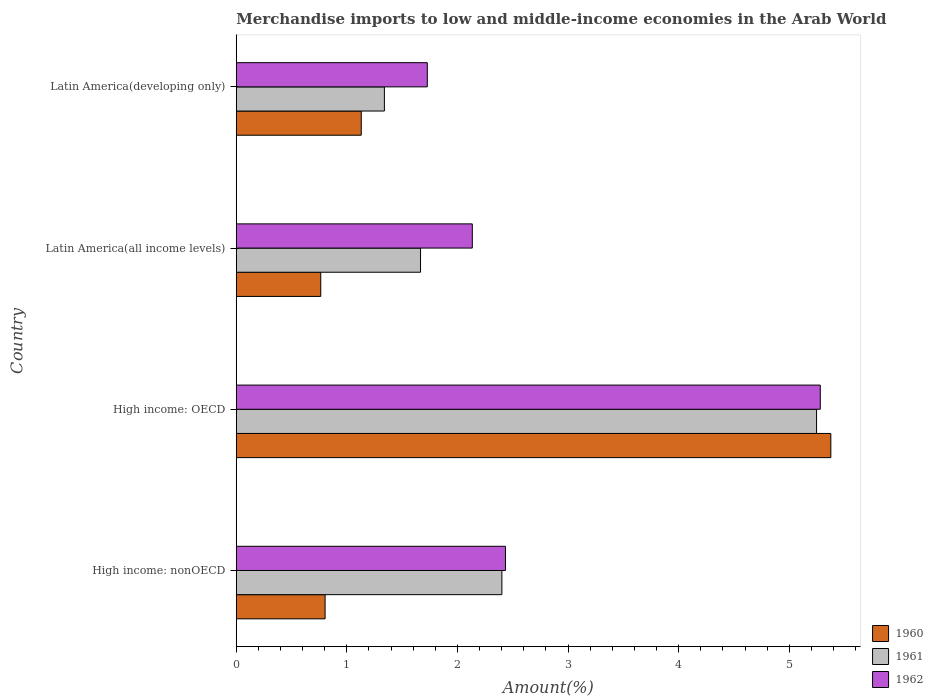How many different coloured bars are there?
Provide a succinct answer. 3. How many groups of bars are there?
Offer a terse response. 4. Are the number of bars per tick equal to the number of legend labels?
Your answer should be compact. Yes. How many bars are there on the 2nd tick from the top?
Offer a very short reply. 3. How many bars are there on the 3rd tick from the bottom?
Your response must be concise. 3. What is the label of the 3rd group of bars from the top?
Give a very brief answer. High income: OECD. What is the percentage of amount earned from merchandise imports in 1962 in Latin America(developing only)?
Make the answer very short. 1.73. Across all countries, what is the maximum percentage of amount earned from merchandise imports in 1961?
Ensure brevity in your answer.  5.25. Across all countries, what is the minimum percentage of amount earned from merchandise imports in 1962?
Give a very brief answer. 1.73. In which country was the percentage of amount earned from merchandise imports in 1962 maximum?
Provide a succinct answer. High income: OECD. In which country was the percentage of amount earned from merchandise imports in 1962 minimum?
Offer a very short reply. Latin America(developing only). What is the total percentage of amount earned from merchandise imports in 1962 in the graph?
Keep it short and to the point. 11.57. What is the difference between the percentage of amount earned from merchandise imports in 1960 in Latin America(all income levels) and that in Latin America(developing only)?
Ensure brevity in your answer.  -0.37. What is the difference between the percentage of amount earned from merchandise imports in 1960 in Latin America(all income levels) and the percentage of amount earned from merchandise imports in 1962 in Latin America(developing only)?
Your answer should be very brief. -0.96. What is the average percentage of amount earned from merchandise imports in 1962 per country?
Give a very brief answer. 2.89. What is the difference between the percentage of amount earned from merchandise imports in 1960 and percentage of amount earned from merchandise imports in 1962 in Latin America(all income levels)?
Make the answer very short. -1.37. What is the ratio of the percentage of amount earned from merchandise imports in 1960 in Latin America(all income levels) to that in Latin America(developing only)?
Your answer should be very brief. 0.68. Is the difference between the percentage of amount earned from merchandise imports in 1960 in High income: nonOECD and Latin America(all income levels) greater than the difference between the percentage of amount earned from merchandise imports in 1962 in High income: nonOECD and Latin America(all income levels)?
Your response must be concise. No. What is the difference between the highest and the second highest percentage of amount earned from merchandise imports in 1960?
Keep it short and to the point. 4.25. What is the difference between the highest and the lowest percentage of amount earned from merchandise imports in 1962?
Your answer should be very brief. 3.55. Is the sum of the percentage of amount earned from merchandise imports in 1960 in High income: OECD and Latin America(all income levels) greater than the maximum percentage of amount earned from merchandise imports in 1962 across all countries?
Provide a short and direct response. Yes. What does the 2nd bar from the top in Latin America(all income levels) represents?
Ensure brevity in your answer.  1961. What does the 2nd bar from the bottom in High income: nonOECD represents?
Provide a succinct answer. 1961. Is it the case that in every country, the sum of the percentage of amount earned from merchandise imports in 1961 and percentage of amount earned from merchandise imports in 1962 is greater than the percentage of amount earned from merchandise imports in 1960?
Your answer should be very brief. Yes. What is the difference between two consecutive major ticks on the X-axis?
Offer a very short reply. 1. Does the graph contain any zero values?
Keep it short and to the point. No. How many legend labels are there?
Your answer should be very brief. 3. What is the title of the graph?
Give a very brief answer. Merchandise imports to low and middle-income economies in the Arab World. What is the label or title of the X-axis?
Give a very brief answer. Amount(%). What is the Amount(%) in 1960 in High income: nonOECD?
Make the answer very short. 0.8. What is the Amount(%) in 1961 in High income: nonOECD?
Provide a succinct answer. 2.4. What is the Amount(%) in 1962 in High income: nonOECD?
Give a very brief answer. 2.43. What is the Amount(%) in 1960 in High income: OECD?
Provide a succinct answer. 5.38. What is the Amount(%) of 1961 in High income: OECD?
Ensure brevity in your answer.  5.25. What is the Amount(%) of 1962 in High income: OECD?
Your answer should be very brief. 5.28. What is the Amount(%) in 1960 in Latin America(all income levels)?
Provide a succinct answer. 0.76. What is the Amount(%) of 1961 in Latin America(all income levels)?
Your response must be concise. 1.67. What is the Amount(%) of 1962 in Latin America(all income levels)?
Your answer should be compact. 2.13. What is the Amount(%) in 1960 in Latin America(developing only)?
Keep it short and to the point. 1.13. What is the Amount(%) of 1961 in Latin America(developing only)?
Your response must be concise. 1.34. What is the Amount(%) in 1962 in Latin America(developing only)?
Make the answer very short. 1.73. Across all countries, what is the maximum Amount(%) in 1960?
Ensure brevity in your answer.  5.38. Across all countries, what is the maximum Amount(%) in 1961?
Make the answer very short. 5.25. Across all countries, what is the maximum Amount(%) of 1962?
Keep it short and to the point. 5.28. Across all countries, what is the minimum Amount(%) in 1960?
Provide a succinct answer. 0.76. Across all countries, what is the minimum Amount(%) of 1961?
Give a very brief answer. 1.34. Across all countries, what is the minimum Amount(%) in 1962?
Offer a very short reply. 1.73. What is the total Amount(%) in 1960 in the graph?
Your response must be concise. 8.07. What is the total Amount(%) of 1961 in the graph?
Make the answer very short. 10.65. What is the total Amount(%) of 1962 in the graph?
Ensure brevity in your answer.  11.57. What is the difference between the Amount(%) of 1960 in High income: nonOECD and that in High income: OECD?
Ensure brevity in your answer.  -4.57. What is the difference between the Amount(%) of 1961 in High income: nonOECD and that in High income: OECD?
Provide a short and direct response. -2.84. What is the difference between the Amount(%) in 1962 in High income: nonOECD and that in High income: OECD?
Provide a succinct answer. -2.85. What is the difference between the Amount(%) of 1960 in High income: nonOECD and that in Latin America(all income levels)?
Ensure brevity in your answer.  0.04. What is the difference between the Amount(%) in 1961 in High income: nonOECD and that in Latin America(all income levels)?
Provide a short and direct response. 0.74. What is the difference between the Amount(%) of 1962 in High income: nonOECD and that in Latin America(all income levels)?
Your response must be concise. 0.3. What is the difference between the Amount(%) of 1960 in High income: nonOECD and that in Latin America(developing only)?
Provide a short and direct response. -0.33. What is the difference between the Amount(%) in 1961 in High income: nonOECD and that in Latin America(developing only)?
Give a very brief answer. 1.06. What is the difference between the Amount(%) in 1962 in High income: nonOECD and that in Latin America(developing only)?
Provide a short and direct response. 0.71. What is the difference between the Amount(%) of 1960 in High income: OECD and that in Latin America(all income levels)?
Offer a terse response. 4.61. What is the difference between the Amount(%) of 1961 in High income: OECD and that in Latin America(all income levels)?
Give a very brief answer. 3.58. What is the difference between the Amount(%) in 1962 in High income: OECD and that in Latin America(all income levels)?
Offer a very short reply. 3.15. What is the difference between the Amount(%) in 1960 in High income: OECD and that in Latin America(developing only)?
Give a very brief answer. 4.25. What is the difference between the Amount(%) of 1961 in High income: OECD and that in Latin America(developing only)?
Offer a very short reply. 3.91. What is the difference between the Amount(%) in 1962 in High income: OECD and that in Latin America(developing only)?
Your response must be concise. 3.55. What is the difference between the Amount(%) of 1960 in Latin America(all income levels) and that in Latin America(developing only)?
Provide a short and direct response. -0.37. What is the difference between the Amount(%) of 1961 in Latin America(all income levels) and that in Latin America(developing only)?
Offer a very short reply. 0.33. What is the difference between the Amount(%) in 1962 in Latin America(all income levels) and that in Latin America(developing only)?
Your answer should be very brief. 0.41. What is the difference between the Amount(%) of 1960 in High income: nonOECD and the Amount(%) of 1961 in High income: OECD?
Offer a very short reply. -4.44. What is the difference between the Amount(%) of 1960 in High income: nonOECD and the Amount(%) of 1962 in High income: OECD?
Provide a succinct answer. -4.48. What is the difference between the Amount(%) of 1961 in High income: nonOECD and the Amount(%) of 1962 in High income: OECD?
Give a very brief answer. -2.88. What is the difference between the Amount(%) of 1960 in High income: nonOECD and the Amount(%) of 1961 in Latin America(all income levels)?
Provide a succinct answer. -0.86. What is the difference between the Amount(%) in 1960 in High income: nonOECD and the Amount(%) in 1962 in Latin America(all income levels)?
Give a very brief answer. -1.33. What is the difference between the Amount(%) in 1961 in High income: nonOECD and the Amount(%) in 1962 in Latin America(all income levels)?
Provide a short and direct response. 0.27. What is the difference between the Amount(%) in 1960 in High income: nonOECD and the Amount(%) in 1961 in Latin America(developing only)?
Offer a terse response. -0.54. What is the difference between the Amount(%) of 1960 in High income: nonOECD and the Amount(%) of 1962 in Latin America(developing only)?
Keep it short and to the point. -0.92. What is the difference between the Amount(%) of 1961 in High income: nonOECD and the Amount(%) of 1962 in Latin America(developing only)?
Give a very brief answer. 0.67. What is the difference between the Amount(%) in 1960 in High income: OECD and the Amount(%) in 1961 in Latin America(all income levels)?
Ensure brevity in your answer.  3.71. What is the difference between the Amount(%) in 1960 in High income: OECD and the Amount(%) in 1962 in Latin America(all income levels)?
Your response must be concise. 3.24. What is the difference between the Amount(%) in 1961 in High income: OECD and the Amount(%) in 1962 in Latin America(all income levels)?
Provide a succinct answer. 3.11. What is the difference between the Amount(%) in 1960 in High income: OECD and the Amount(%) in 1961 in Latin America(developing only)?
Offer a terse response. 4.04. What is the difference between the Amount(%) of 1960 in High income: OECD and the Amount(%) of 1962 in Latin America(developing only)?
Ensure brevity in your answer.  3.65. What is the difference between the Amount(%) of 1961 in High income: OECD and the Amount(%) of 1962 in Latin America(developing only)?
Provide a succinct answer. 3.52. What is the difference between the Amount(%) of 1960 in Latin America(all income levels) and the Amount(%) of 1961 in Latin America(developing only)?
Your response must be concise. -0.58. What is the difference between the Amount(%) in 1960 in Latin America(all income levels) and the Amount(%) in 1962 in Latin America(developing only)?
Keep it short and to the point. -0.96. What is the difference between the Amount(%) in 1961 in Latin America(all income levels) and the Amount(%) in 1962 in Latin America(developing only)?
Your answer should be compact. -0.06. What is the average Amount(%) in 1960 per country?
Your response must be concise. 2.02. What is the average Amount(%) of 1961 per country?
Offer a terse response. 2.66. What is the average Amount(%) in 1962 per country?
Provide a succinct answer. 2.89. What is the difference between the Amount(%) in 1960 and Amount(%) in 1961 in High income: nonOECD?
Offer a very short reply. -1.6. What is the difference between the Amount(%) of 1960 and Amount(%) of 1962 in High income: nonOECD?
Give a very brief answer. -1.63. What is the difference between the Amount(%) of 1961 and Amount(%) of 1962 in High income: nonOECD?
Your answer should be compact. -0.03. What is the difference between the Amount(%) of 1960 and Amount(%) of 1961 in High income: OECD?
Give a very brief answer. 0.13. What is the difference between the Amount(%) of 1960 and Amount(%) of 1962 in High income: OECD?
Your answer should be very brief. 0.1. What is the difference between the Amount(%) in 1961 and Amount(%) in 1962 in High income: OECD?
Give a very brief answer. -0.03. What is the difference between the Amount(%) in 1960 and Amount(%) in 1961 in Latin America(all income levels)?
Your answer should be very brief. -0.9. What is the difference between the Amount(%) in 1960 and Amount(%) in 1962 in Latin America(all income levels)?
Your answer should be compact. -1.37. What is the difference between the Amount(%) in 1961 and Amount(%) in 1962 in Latin America(all income levels)?
Offer a very short reply. -0.47. What is the difference between the Amount(%) in 1960 and Amount(%) in 1961 in Latin America(developing only)?
Ensure brevity in your answer.  -0.21. What is the difference between the Amount(%) in 1960 and Amount(%) in 1962 in Latin America(developing only)?
Provide a short and direct response. -0.6. What is the difference between the Amount(%) in 1961 and Amount(%) in 1962 in Latin America(developing only)?
Offer a terse response. -0.39. What is the ratio of the Amount(%) in 1960 in High income: nonOECD to that in High income: OECD?
Ensure brevity in your answer.  0.15. What is the ratio of the Amount(%) of 1961 in High income: nonOECD to that in High income: OECD?
Keep it short and to the point. 0.46. What is the ratio of the Amount(%) of 1962 in High income: nonOECD to that in High income: OECD?
Offer a very short reply. 0.46. What is the ratio of the Amount(%) in 1960 in High income: nonOECD to that in Latin America(all income levels)?
Offer a very short reply. 1.05. What is the ratio of the Amount(%) in 1961 in High income: nonOECD to that in Latin America(all income levels)?
Offer a very short reply. 1.44. What is the ratio of the Amount(%) of 1962 in High income: nonOECD to that in Latin America(all income levels)?
Your answer should be very brief. 1.14. What is the ratio of the Amount(%) in 1960 in High income: nonOECD to that in Latin America(developing only)?
Your response must be concise. 0.71. What is the ratio of the Amount(%) in 1961 in High income: nonOECD to that in Latin America(developing only)?
Keep it short and to the point. 1.79. What is the ratio of the Amount(%) of 1962 in High income: nonOECD to that in Latin America(developing only)?
Keep it short and to the point. 1.41. What is the ratio of the Amount(%) in 1960 in High income: OECD to that in Latin America(all income levels)?
Your answer should be compact. 7.04. What is the ratio of the Amount(%) of 1961 in High income: OECD to that in Latin America(all income levels)?
Provide a short and direct response. 3.15. What is the ratio of the Amount(%) in 1962 in High income: OECD to that in Latin America(all income levels)?
Ensure brevity in your answer.  2.47. What is the ratio of the Amount(%) in 1960 in High income: OECD to that in Latin America(developing only)?
Offer a terse response. 4.76. What is the ratio of the Amount(%) in 1961 in High income: OECD to that in Latin America(developing only)?
Give a very brief answer. 3.92. What is the ratio of the Amount(%) of 1962 in High income: OECD to that in Latin America(developing only)?
Your response must be concise. 3.06. What is the ratio of the Amount(%) of 1960 in Latin America(all income levels) to that in Latin America(developing only)?
Offer a terse response. 0.68. What is the ratio of the Amount(%) in 1961 in Latin America(all income levels) to that in Latin America(developing only)?
Ensure brevity in your answer.  1.24. What is the ratio of the Amount(%) in 1962 in Latin America(all income levels) to that in Latin America(developing only)?
Make the answer very short. 1.24. What is the difference between the highest and the second highest Amount(%) in 1960?
Provide a short and direct response. 4.25. What is the difference between the highest and the second highest Amount(%) in 1961?
Give a very brief answer. 2.84. What is the difference between the highest and the second highest Amount(%) of 1962?
Offer a terse response. 2.85. What is the difference between the highest and the lowest Amount(%) in 1960?
Your answer should be compact. 4.61. What is the difference between the highest and the lowest Amount(%) of 1961?
Ensure brevity in your answer.  3.91. What is the difference between the highest and the lowest Amount(%) in 1962?
Provide a short and direct response. 3.55. 